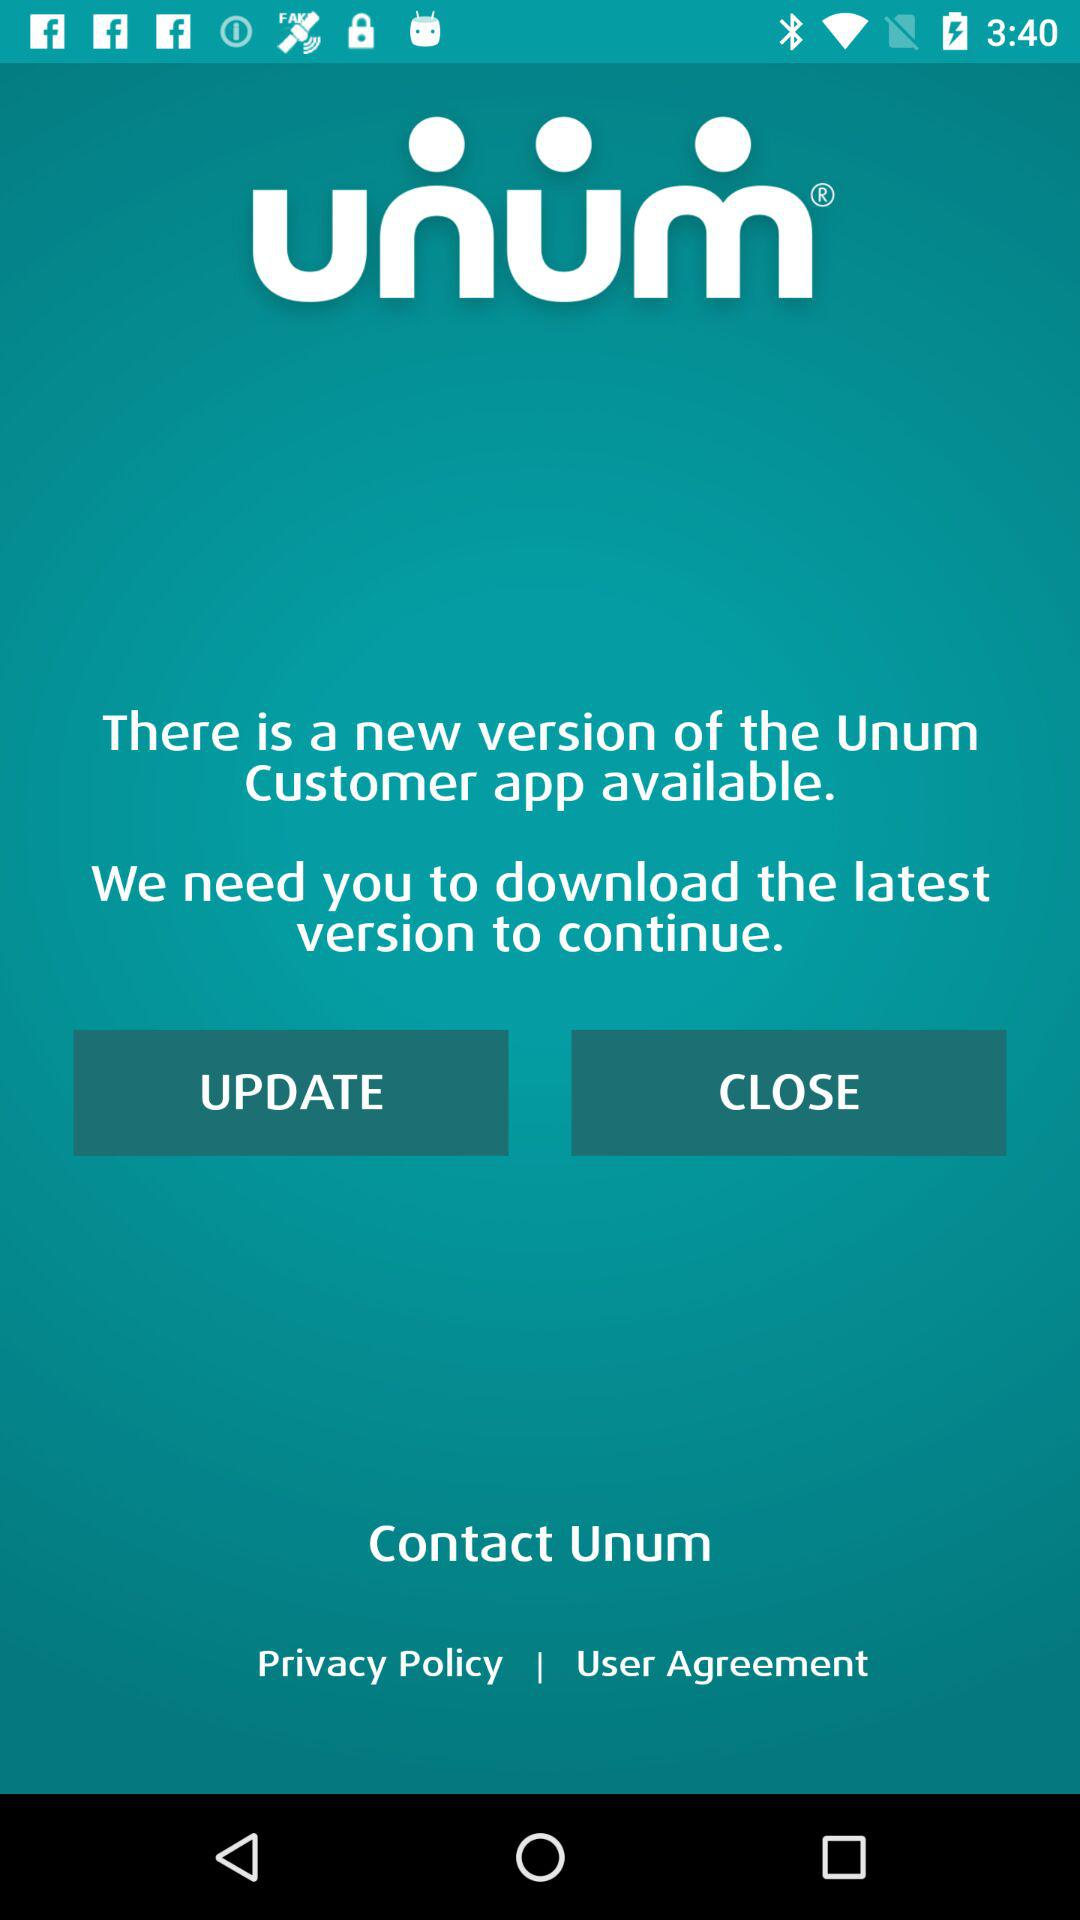What is the application name? The application name is "Unum". 